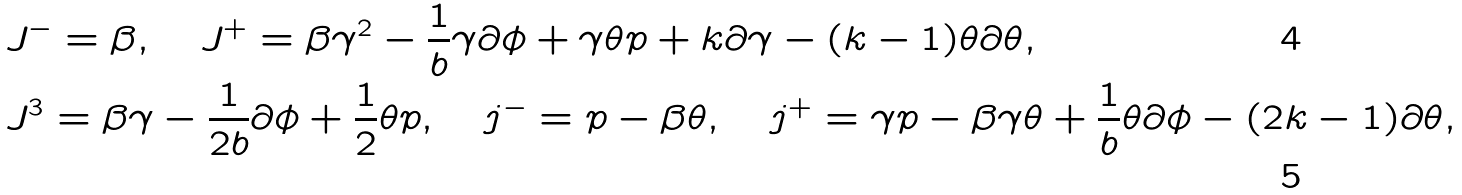Convert formula to latex. <formula><loc_0><loc_0><loc_500><loc_500>& J ^ { - } = \beta , \quad J ^ { + } = \beta \gamma ^ { 2 } - \frac { 1 } { b } \gamma \partial \phi + \gamma \theta p + k \partial \gamma - ( k - 1 ) \theta \partial \theta , \\ & J ^ { 3 } = \beta \gamma - \frac { 1 } { 2 b } \partial \phi + \frac { 1 } { 2 } \theta p , \quad j ^ { - } = p - \beta \theta , \quad j ^ { + } = \gamma p - \beta \gamma \theta + \frac { 1 } { b } \theta \partial \phi - ( 2 k - 1 ) \partial \theta ,</formula> 